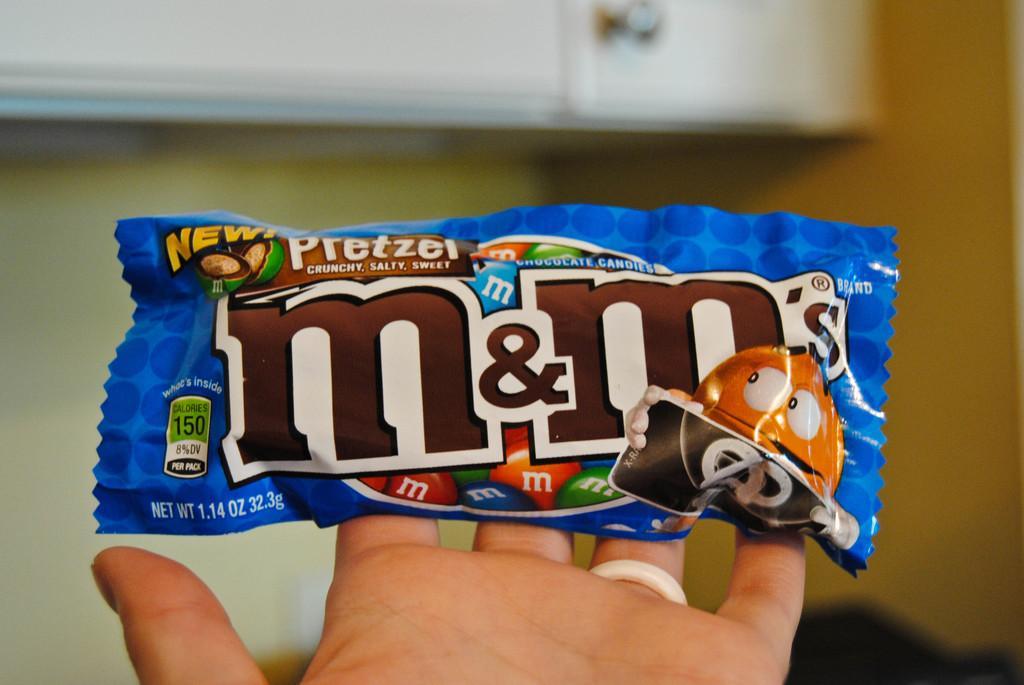Could you give a brief overview of what you see in this image? This image is taken indoors. In the background there is a wall and there is a cupboard. In the middle of the image there is a person's hand and there is a chocolate packet in the hand. 